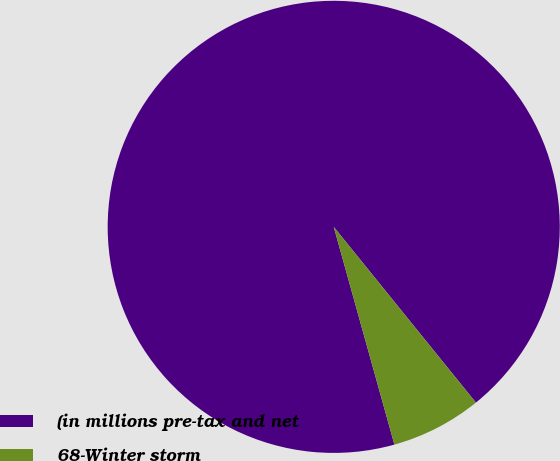Convert chart. <chart><loc_0><loc_0><loc_500><loc_500><pie_chart><fcel>(in millions pre-tax and net<fcel>68-Winter storm<nl><fcel>93.5%<fcel>6.5%<nl></chart> 